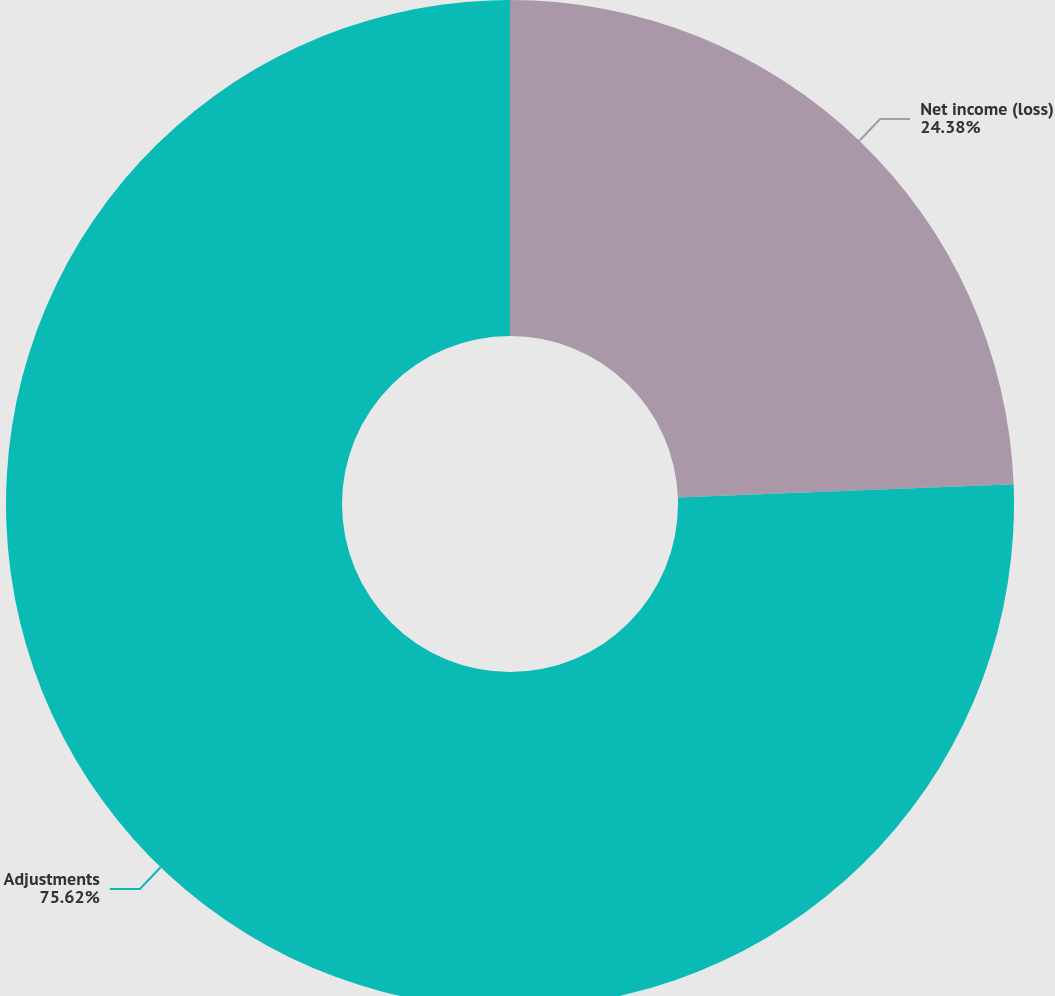<chart> <loc_0><loc_0><loc_500><loc_500><pie_chart><fcel>Net income (loss)<fcel>Adjustments<nl><fcel>24.38%<fcel>75.62%<nl></chart> 